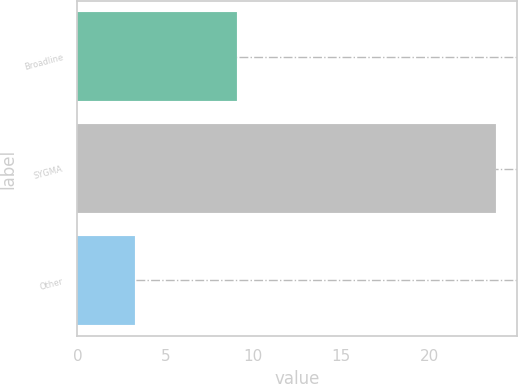Convert chart. <chart><loc_0><loc_0><loc_500><loc_500><bar_chart><fcel>Broadline<fcel>SYGMA<fcel>Other<nl><fcel>9.1<fcel>23.8<fcel>3.3<nl></chart> 